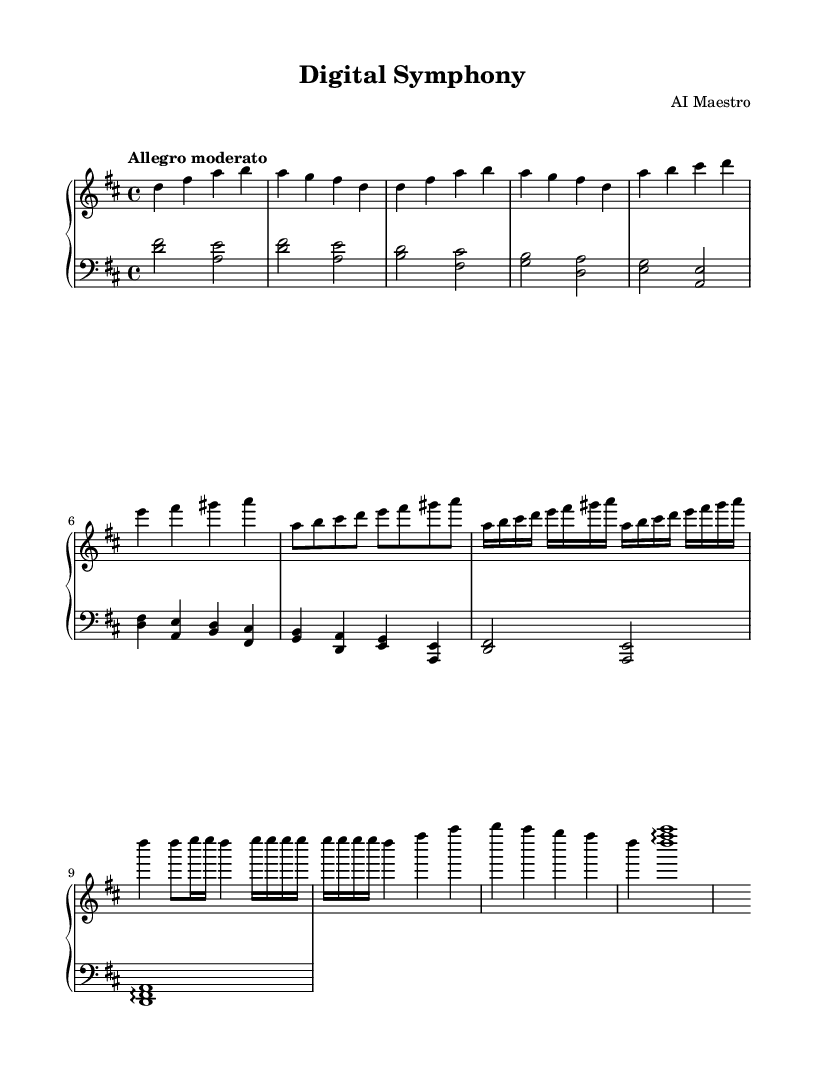What is the key signature of this music? The key signature is indicated by the sharps or flats placed at the beginning of the staff. In this case, it shows two sharps, which corresponds to D major.
Answer: D major What is the time signature of this music? The time signature is shown at the beginning of the staff, where the top number represents the number of beats per measure and the bottom number indicates the note value of each beat. Here, 4/4 means there are 4 beats per measure, and the quarter note gets the beat.
Answer: 4/4 What is the tempo marking for this composition? The tempo marking is written above the staff and describes how fast the piece should be played. The term "Allegro moderato" indicates a moderate speed.
Answer: Allegro moderato How many measures are in the entire piece? By counting the measures as represented by the vertical lines in the music, we see that there are a total of 20 measures in this composition.
Answer: 20 What is the first theme of the composition referred to as? The first theme is identified in the sheet music and is labeled as Theme A, which is clearly stated. This theme explores a motif that relates to the concept of clouds.
Answer: Cloud Motif How does the Development section utilize rhythmic patterns? The Development section emphasizes the use of various rhythmic values and varying the rhythms within the measures to heighten the musical complexity and interest. It uses 16th notes prominently, indicating a faster rhythmic feel.
Answer: Rhythmic patterns What does the Coda signify in this composition? The Coda marks the concluding section of the piece. It is indicated at the end of the music and brings closure to the themes that have been presented throughout the composition.
Answer: Coda 